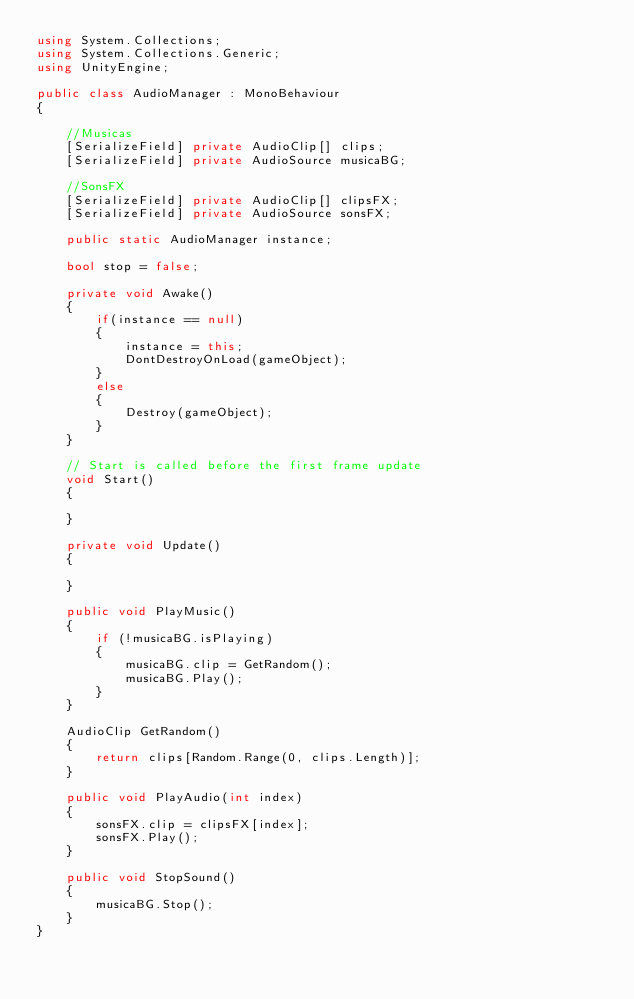Convert code to text. <code><loc_0><loc_0><loc_500><loc_500><_C#_>using System.Collections;
using System.Collections.Generic;
using UnityEngine;

public class AudioManager : MonoBehaviour
{

    //Musicas
    [SerializeField] private AudioClip[] clips;
    [SerializeField] private AudioSource musicaBG;

    //SonsFX
    [SerializeField] private AudioClip[] clipsFX;
    [SerializeField] private AudioSource sonsFX;

    public static AudioManager instance;

    bool stop = false;

    private void Awake()
    {
        if(instance == null)
        {
            instance = this;
            DontDestroyOnLoad(gameObject);
        }
        else
        {
            Destroy(gameObject);
        }
    }

    // Start is called before the first frame update
    void Start()
    {
        
    }

    private void Update()
    {
        
    }

    public void PlayMusic()
    {
        if (!musicaBG.isPlaying)
        {
            musicaBG.clip = GetRandom();
            musicaBG.Play();
        }
    }

    AudioClip GetRandom()
    {
        return clips[Random.Range(0, clips.Length)];
    }

    public void PlayAudio(int index)
    {
        sonsFX.clip = clipsFX[index];
        sonsFX.Play();
    }

    public void StopSound()
    {
        musicaBG.Stop();
    }
}
</code> 